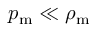<formula> <loc_0><loc_0><loc_500><loc_500>p _ { \mathrm m } \ll \rho _ { \mathrm m }</formula> 